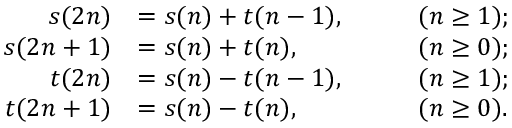<formula> <loc_0><loc_0><loc_500><loc_500>\begin{array} { r l r l } { s ( 2 n ) } & { = s ( n ) + t ( n - 1 ) , } & & { \quad ( n \geq 1 ) ; } \\ { s ( 2 n + 1 ) } & { = s ( n ) + t ( n ) , } & & { \quad ( n \geq 0 ) ; } \\ { t ( 2 n ) } & { = s ( n ) - t ( n - 1 ) , } & & { \quad ( n \geq 1 ) ; } \\ { t ( 2 n + 1 ) } & { = s ( n ) - t ( n ) , } & & { \quad ( n \geq 0 ) . } \end{array}</formula> 